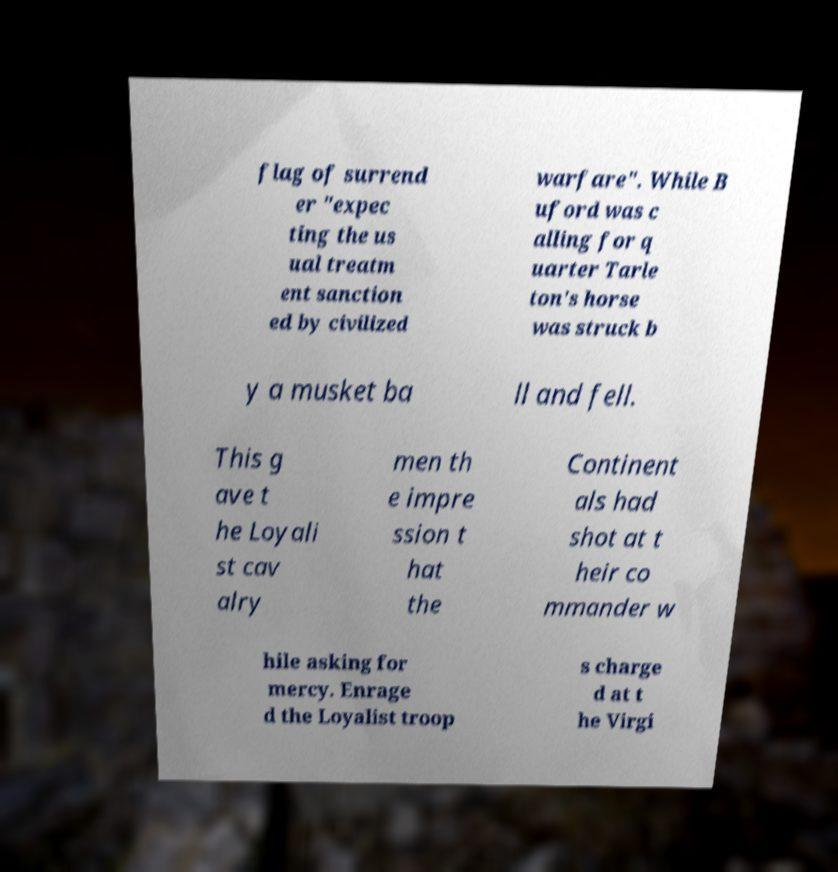Could you assist in decoding the text presented in this image and type it out clearly? flag of surrend er "expec ting the us ual treatm ent sanction ed by civilized warfare". While B uford was c alling for q uarter Tarle ton's horse was struck b y a musket ba ll and fell. This g ave t he Loyali st cav alry men th e impre ssion t hat the Continent als had shot at t heir co mmander w hile asking for mercy. Enrage d the Loyalist troop s charge d at t he Virgi 